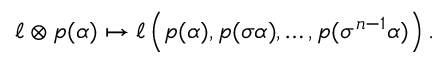<formula> <loc_0><loc_0><loc_500><loc_500>\ell \otimes p ( \alpha ) \mapsto \ell \left ( p ( \alpha ) , p ( \sigma \alpha ) , \dots , p ( \sigma ^ { n - 1 } \alpha ) \right ) .</formula> 